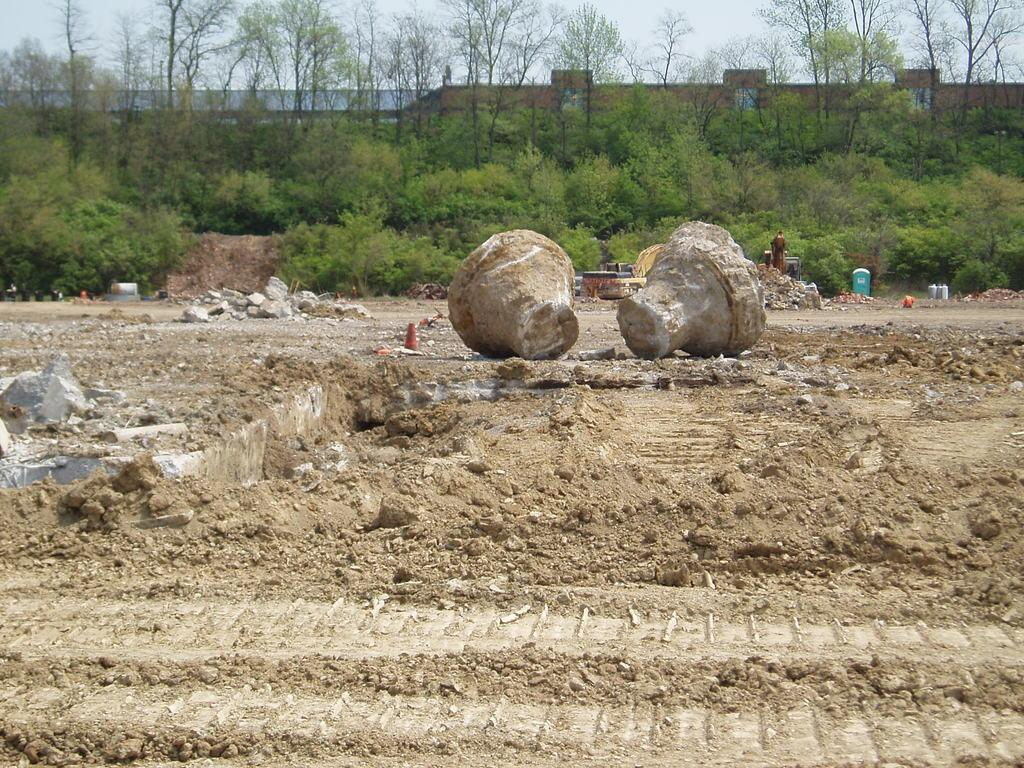What is the primary surface visible in the image? There is a ground in the image. What objects can be seen on the ground in the image? There are two rocks in the image. What can be seen in the distance in the image? There are many trees and plants in the background of the image. What type of teeth can be seen in the image? There are no teeth visible in the image. What mode of transportation is used for the trip in the image? There is no trip or mode of transportation present in the image. 